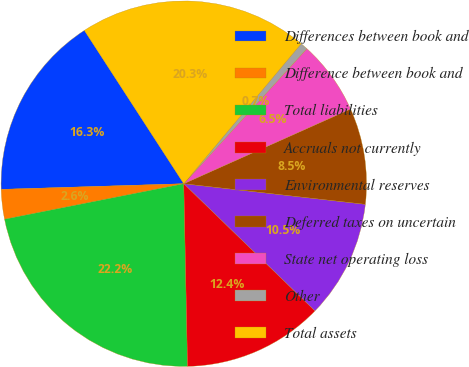<chart> <loc_0><loc_0><loc_500><loc_500><pie_chart><fcel>Differences between book and<fcel>Difference between book and<fcel>Total liabilities<fcel>Accruals not currently<fcel>Environmental reserves<fcel>Deferred taxes on uncertain<fcel>State net operating loss<fcel>Other<fcel>Total assets<nl><fcel>16.34%<fcel>2.62%<fcel>22.22%<fcel>12.42%<fcel>10.46%<fcel>8.5%<fcel>6.54%<fcel>0.66%<fcel>20.26%<nl></chart> 